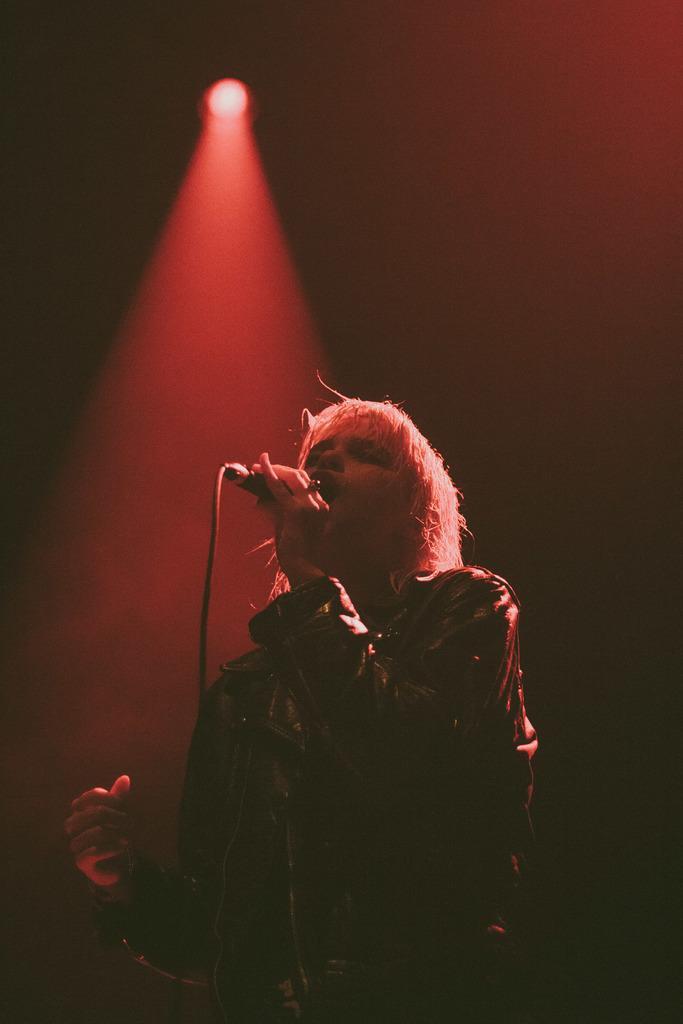Could you give a brief overview of what you see in this image? In this image there is a man, he is holding a mic with his hands, in the top there is a red light. 